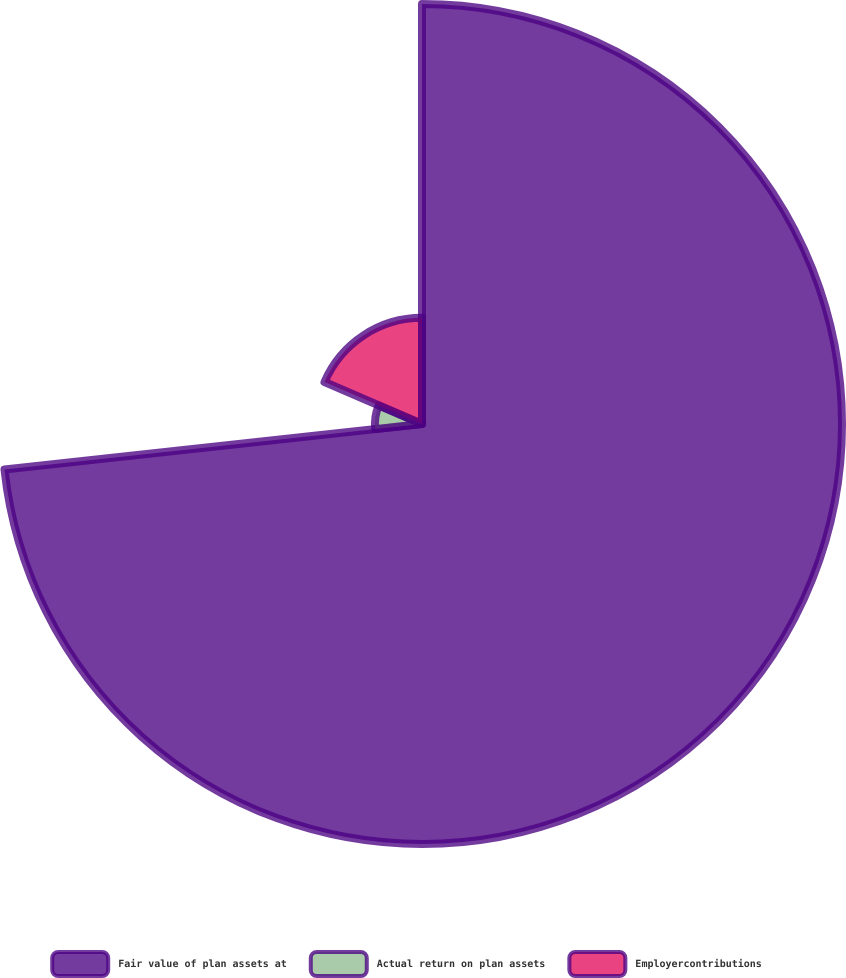Convert chart to OTSL. <chart><loc_0><loc_0><loc_500><loc_500><pie_chart><fcel>Fair value of plan assets at<fcel>Actual return on plan assets<fcel>Employercontributions<nl><fcel>73.27%<fcel>8.21%<fcel>18.52%<nl></chart> 